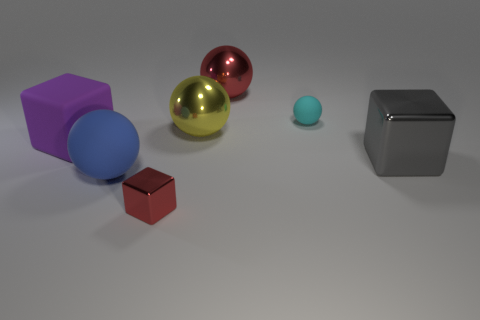Subtract all brown spheres. Subtract all brown blocks. How many spheres are left? 4 Add 1 red metallic cubes. How many objects exist? 8 Subtract all cubes. How many objects are left? 4 Add 7 cylinders. How many cylinders exist? 7 Subtract 0 green spheres. How many objects are left? 7 Subtract all tiny red metallic balls. Subtract all red spheres. How many objects are left? 6 Add 4 tiny shiny cubes. How many tiny shiny cubes are left? 5 